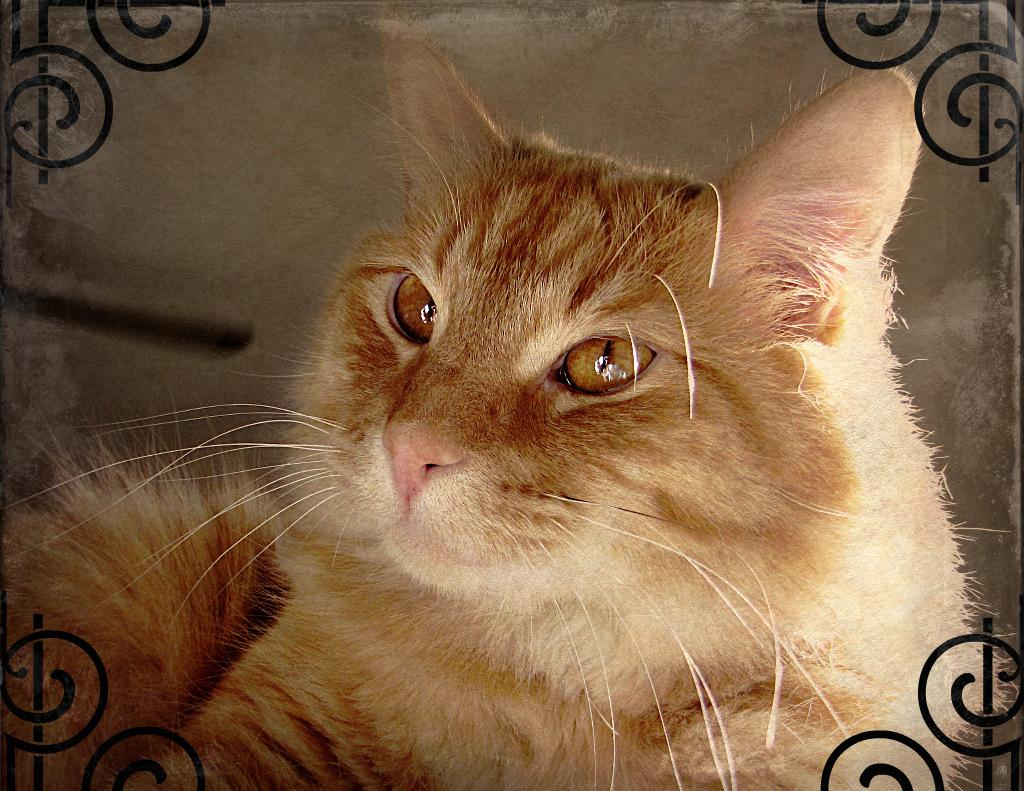What type of animal is in the image? There is a brown color cat in the image. What is the cat doing in the image? The cat is sitting on an object. Can you describe the object the cat is sitting on? The object has designs on the four corners. What can be seen in the background of the image? There is a wall in the background of the image. How many bones can be seen in the image? There are no bones present in the image. What type of bears are interacting with the cat in the image? There are no bears present in the image. 